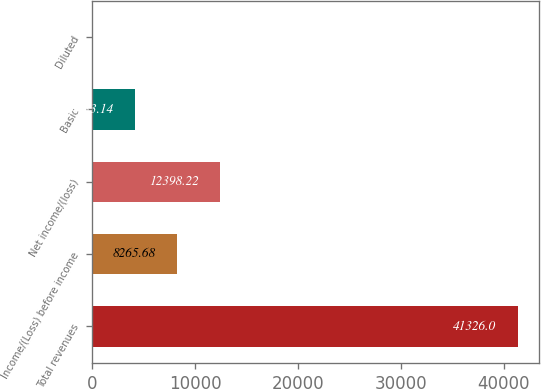Convert chart to OTSL. <chart><loc_0><loc_0><loc_500><loc_500><bar_chart><fcel>Total revenues<fcel>Income/(Loss) before income<fcel>Net income/(loss)<fcel>Basic<fcel>Diluted<nl><fcel>41326<fcel>8265.68<fcel>12398.2<fcel>4133.14<fcel>0.6<nl></chart> 